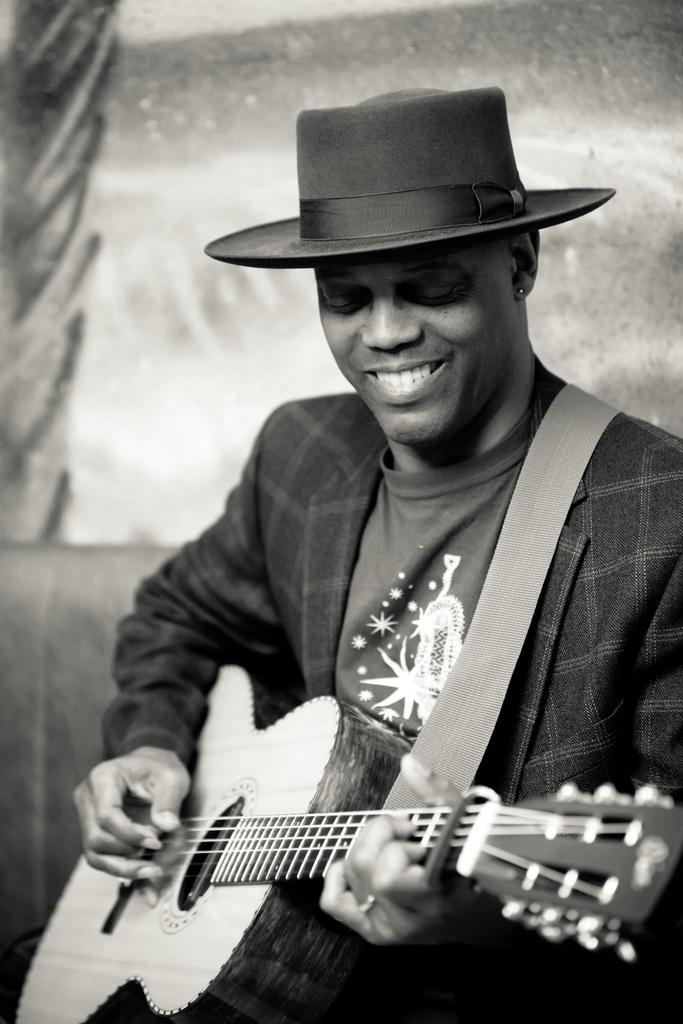What is the color scheme of the image? The image is black and white. Who is present in the image? There is a man in the image. What is the man wearing? The man is wearing a suit and a hat. What is the man holding in the image? The man is holding a guitar. What is the man doing with the guitar? The man is playing the guitar. Does the man's sister appear in the image? There is no mention of a sister in the image, so we cannot determine if she is present. What type of berry can be seen in the man's hand in the image? There are no berries present in the image; the man is holding a guitar. 